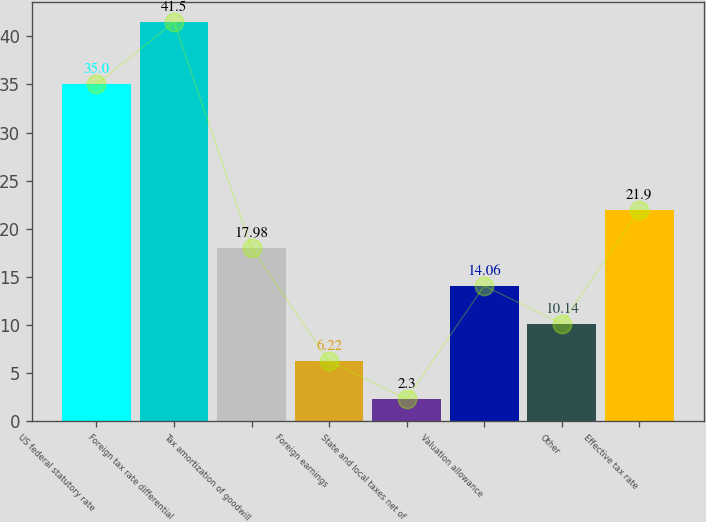Convert chart. <chart><loc_0><loc_0><loc_500><loc_500><bar_chart><fcel>US federal statutory rate<fcel>Foreign tax rate differential<fcel>Tax amortization of goodwill<fcel>Foreign earnings<fcel>State and local taxes net of<fcel>Valuation allowance<fcel>Other<fcel>Effective tax rate<nl><fcel>35<fcel>41.5<fcel>17.98<fcel>6.22<fcel>2.3<fcel>14.06<fcel>10.14<fcel>21.9<nl></chart> 